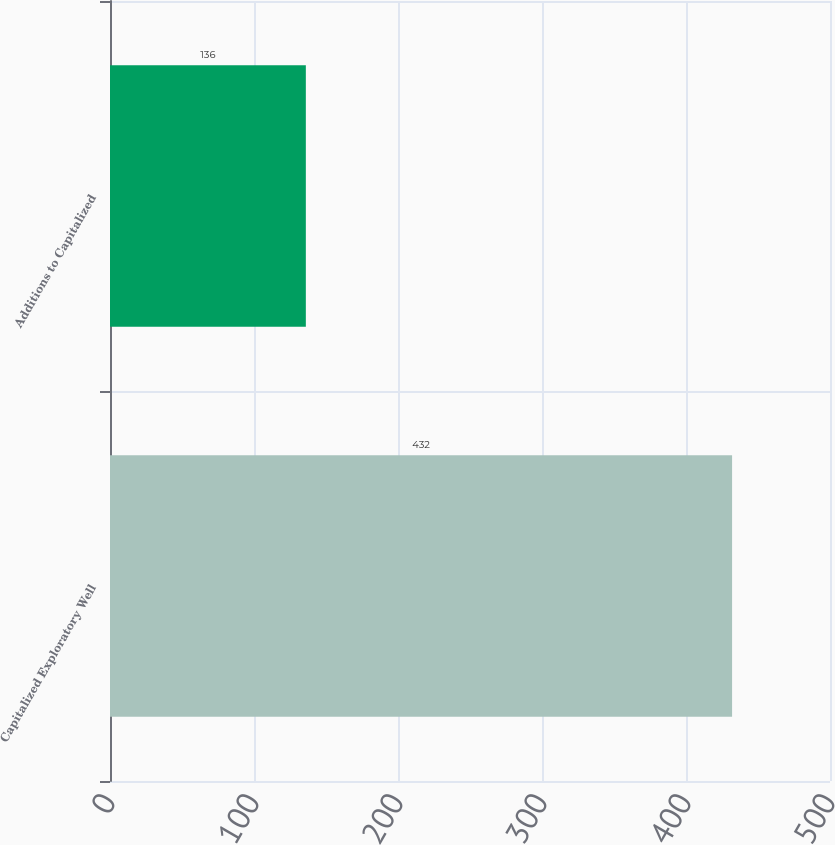Convert chart. <chart><loc_0><loc_0><loc_500><loc_500><bar_chart><fcel>Capitalized Exploratory Well<fcel>Additions to Capitalized<nl><fcel>432<fcel>136<nl></chart> 